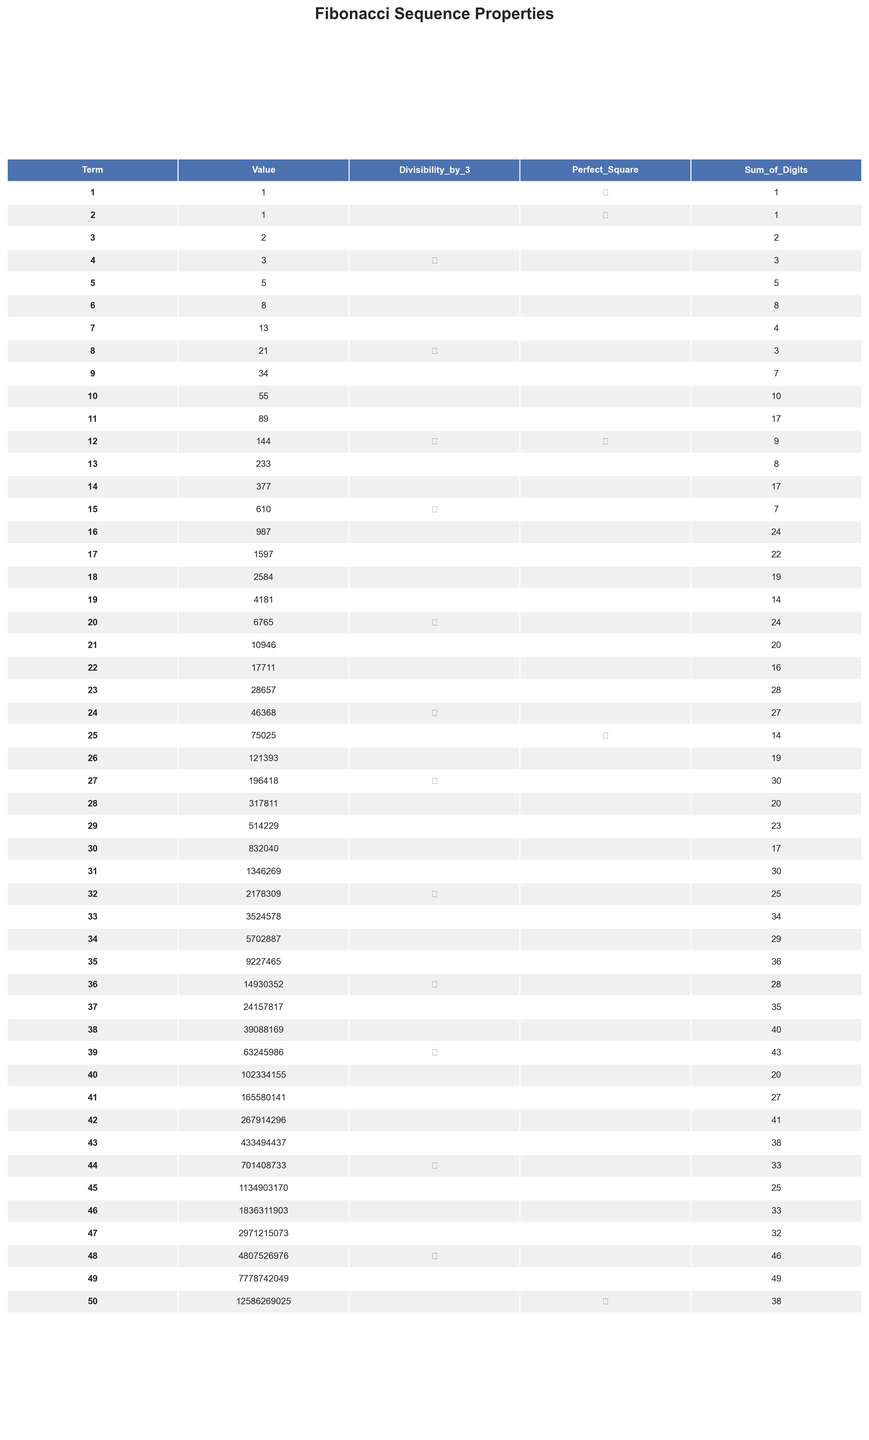What is the value of the 10th term in the Fibonacci sequence? From the table, the value corresponding to the 10th term is 55.
Answer: 55 How many terms in the Fibonacci sequence from the first to the 50th are divisible by 3? The table indicates that 8 terms (3, 8, 12, 15, 20, 24, 27, 36, and 39, and 44, 48) are divisible by 3.
Answer: 10 What is the sum of the digits of the 12th term? Referring to the table, the sum of the digits for the 12th term (144) is 9.
Answer: 9 Is the 24th term a perfect square? The table shows that the 24th term (46368) is not marked as a perfect square, indicating it is not.
Answer: No How many terms among the first 50 Fibonacci numbers are perfect squares? Checking the table, the perfect square terms are for the 1st, 2nd, 12th, 25th, and 36th terms; thus, there are 5 perfect squares.
Answer: 5 Which term has the largest value in the Fibonacci sequence, and what is that value? The 50th term has the largest value, which is 12586269025.
Answer: 12586269025 Is the sum of the digits of the 14th term equal to the sum of the digits of the 15th term? The sum of the digits of the 14th term is 17, and for the 15th term it is 7, which are not equal.
Answer: No What is the average of the sum of the digits of the first 10 terms? Summing the digits of the first 10 terms gives 1 + 1 + 2 + 3 + 5 + 8 + 4 + 3 + 7 + 10 = 40; with 10 terms, the average is 40 / 10 = 4.
Answer: 4 How many terms less than or equal to the 30th term are not divisible by 3? The terms not divisible by 3 among the first 30 Fibonacci numbers are 1, 1, 2, 5, 8, 34, 55, 89, 233, 377, 610, 987, 1597, and 514229, thus 22 terms are not divisible by 3.
Answer: 22 Are there more terms that are divisible by 3 among the first 25 terms or the last 25 terms? The first 25 terms include 8 (3, 8, 12, 15, 20, 24); the last 25 terms also have 8 (36, 39, 44, 48), thus they are equal.
Answer: They are equal 